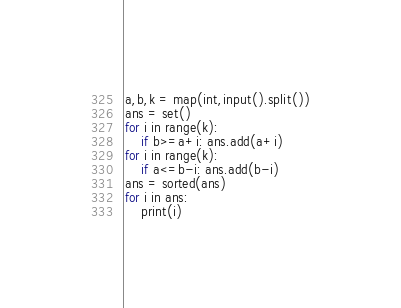Convert code to text. <code><loc_0><loc_0><loc_500><loc_500><_Python_>a,b,k = map(int,input().split())
ans = set()
for i in range(k):
    if b>=a+i: ans.add(a+i)
for i in range(k):
    if a<=b-i: ans.add(b-i)
ans = sorted(ans)
for i in ans:
    print(i)</code> 